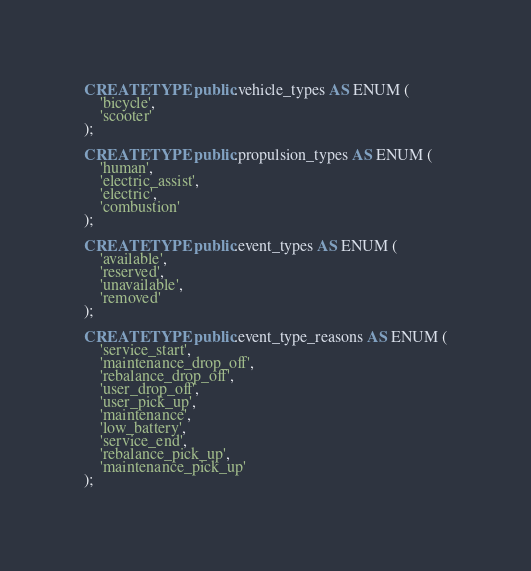Convert code to text. <code><loc_0><loc_0><loc_500><loc_500><_SQL_>CREATE TYPE public.vehicle_types AS ENUM (
    'bicycle',
    'scooter'
);

CREATE TYPE public.propulsion_types AS ENUM (
    'human',
    'electric_assist',
    'electric',
    'combustion'
);

CREATE TYPE public.event_types AS ENUM (
    'available',
    'reserved',
    'unavailable',
    'removed'
);

CREATE TYPE public.event_type_reasons AS ENUM (
    'service_start',
    'maintenance_drop_off',
    'rebalance_drop_off',
    'user_drop_off',
    'user_pick_up',
    'maintenance',
    'low_battery',
    'service_end',
    'rebalance_pick_up',
    'maintenance_pick_up'
);</code> 